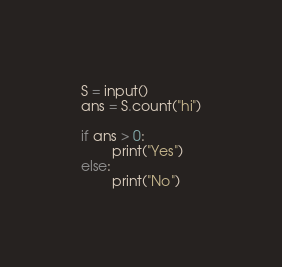Convert code to text. <code><loc_0><loc_0><loc_500><loc_500><_Python_>S = input()
ans = S.count("hi")

if ans > 0:
        print("Yes")
else:
        print("No")
</code> 